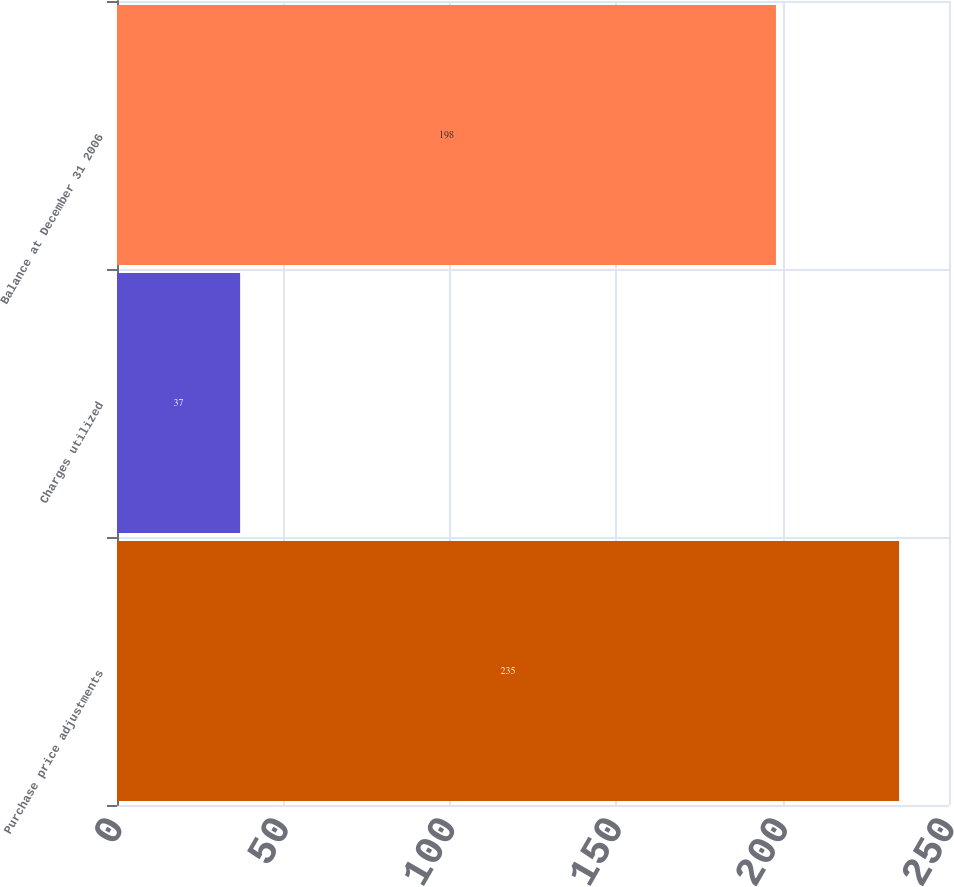Convert chart. <chart><loc_0><loc_0><loc_500><loc_500><bar_chart><fcel>Purchase price adjustments<fcel>Charges utilized<fcel>Balance at December 31 2006<nl><fcel>235<fcel>37<fcel>198<nl></chart> 